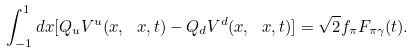<formula> <loc_0><loc_0><loc_500><loc_500>\int _ { - 1 } ^ { 1 } d x [ Q _ { u } V ^ { u } ( x , \ x , t ) - Q _ { d } V ^ { d } ( x , \ x , t ) ] = \sqrt { 2 } f _ { \pi } F _ { \pi \gamma } ( t ) .</formula> 